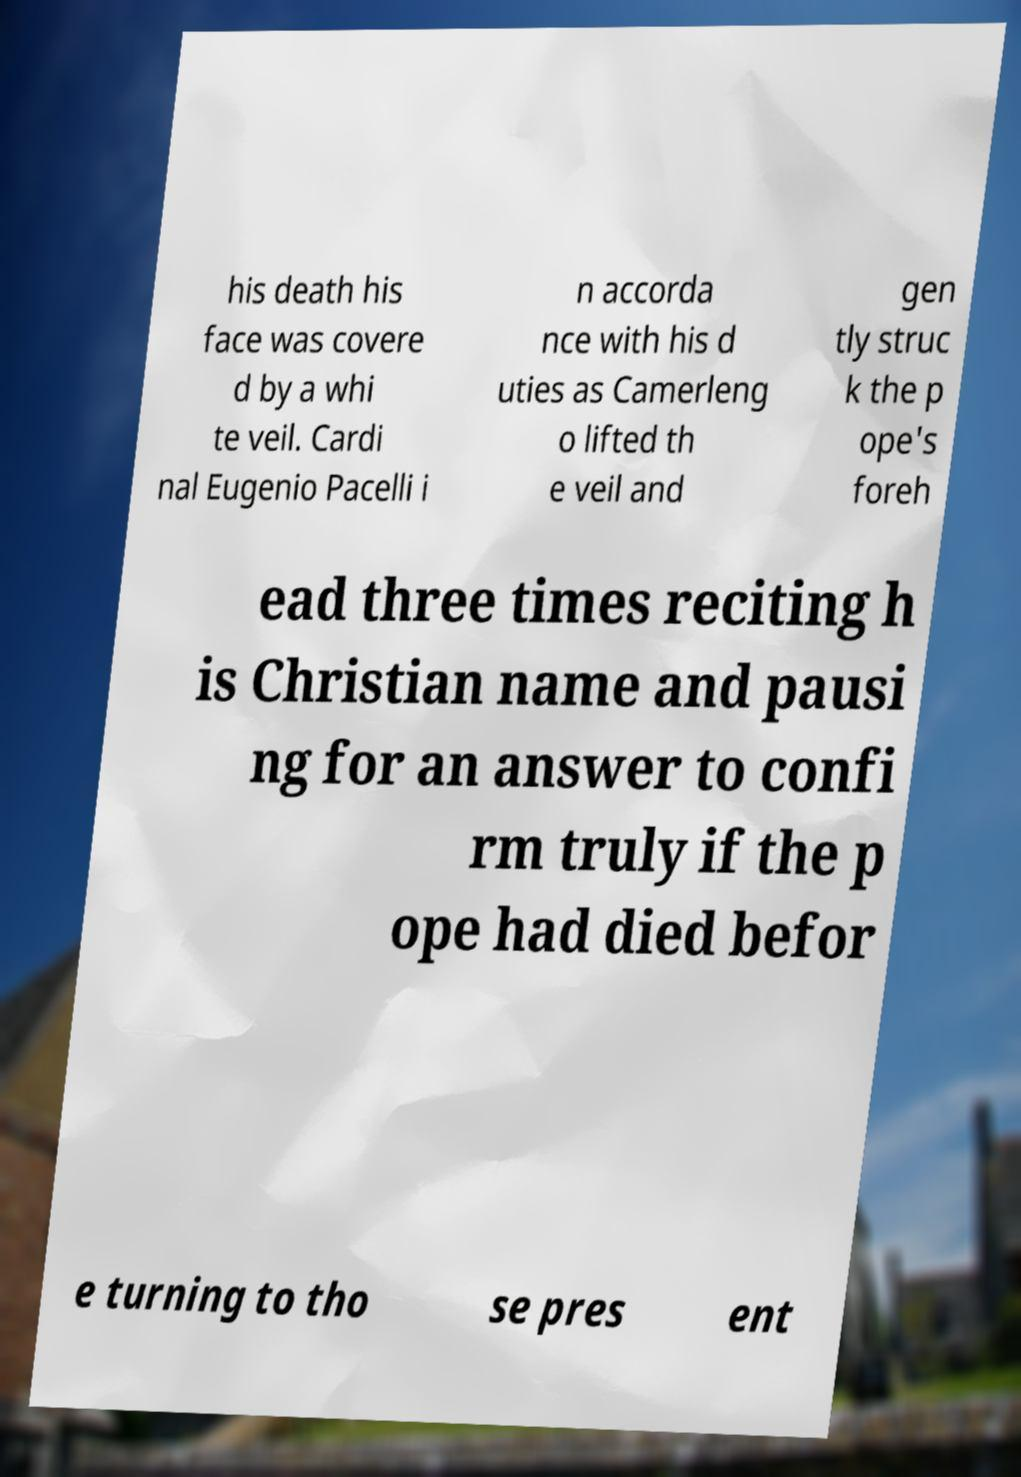I need the written content from this picture converted into text. Can you do that? his death his face was covere d by a whi te veil. Cardi nal Eugenio Pacelli i n accorda nce with his d uties as Camerleng o lifted th e veil and gen tly struc k the p ope's foreh ead three times reciting h is Christian name and pausi ng for an answer to confi rm truly if the p ope had died befor e turning to tho se pres ent 